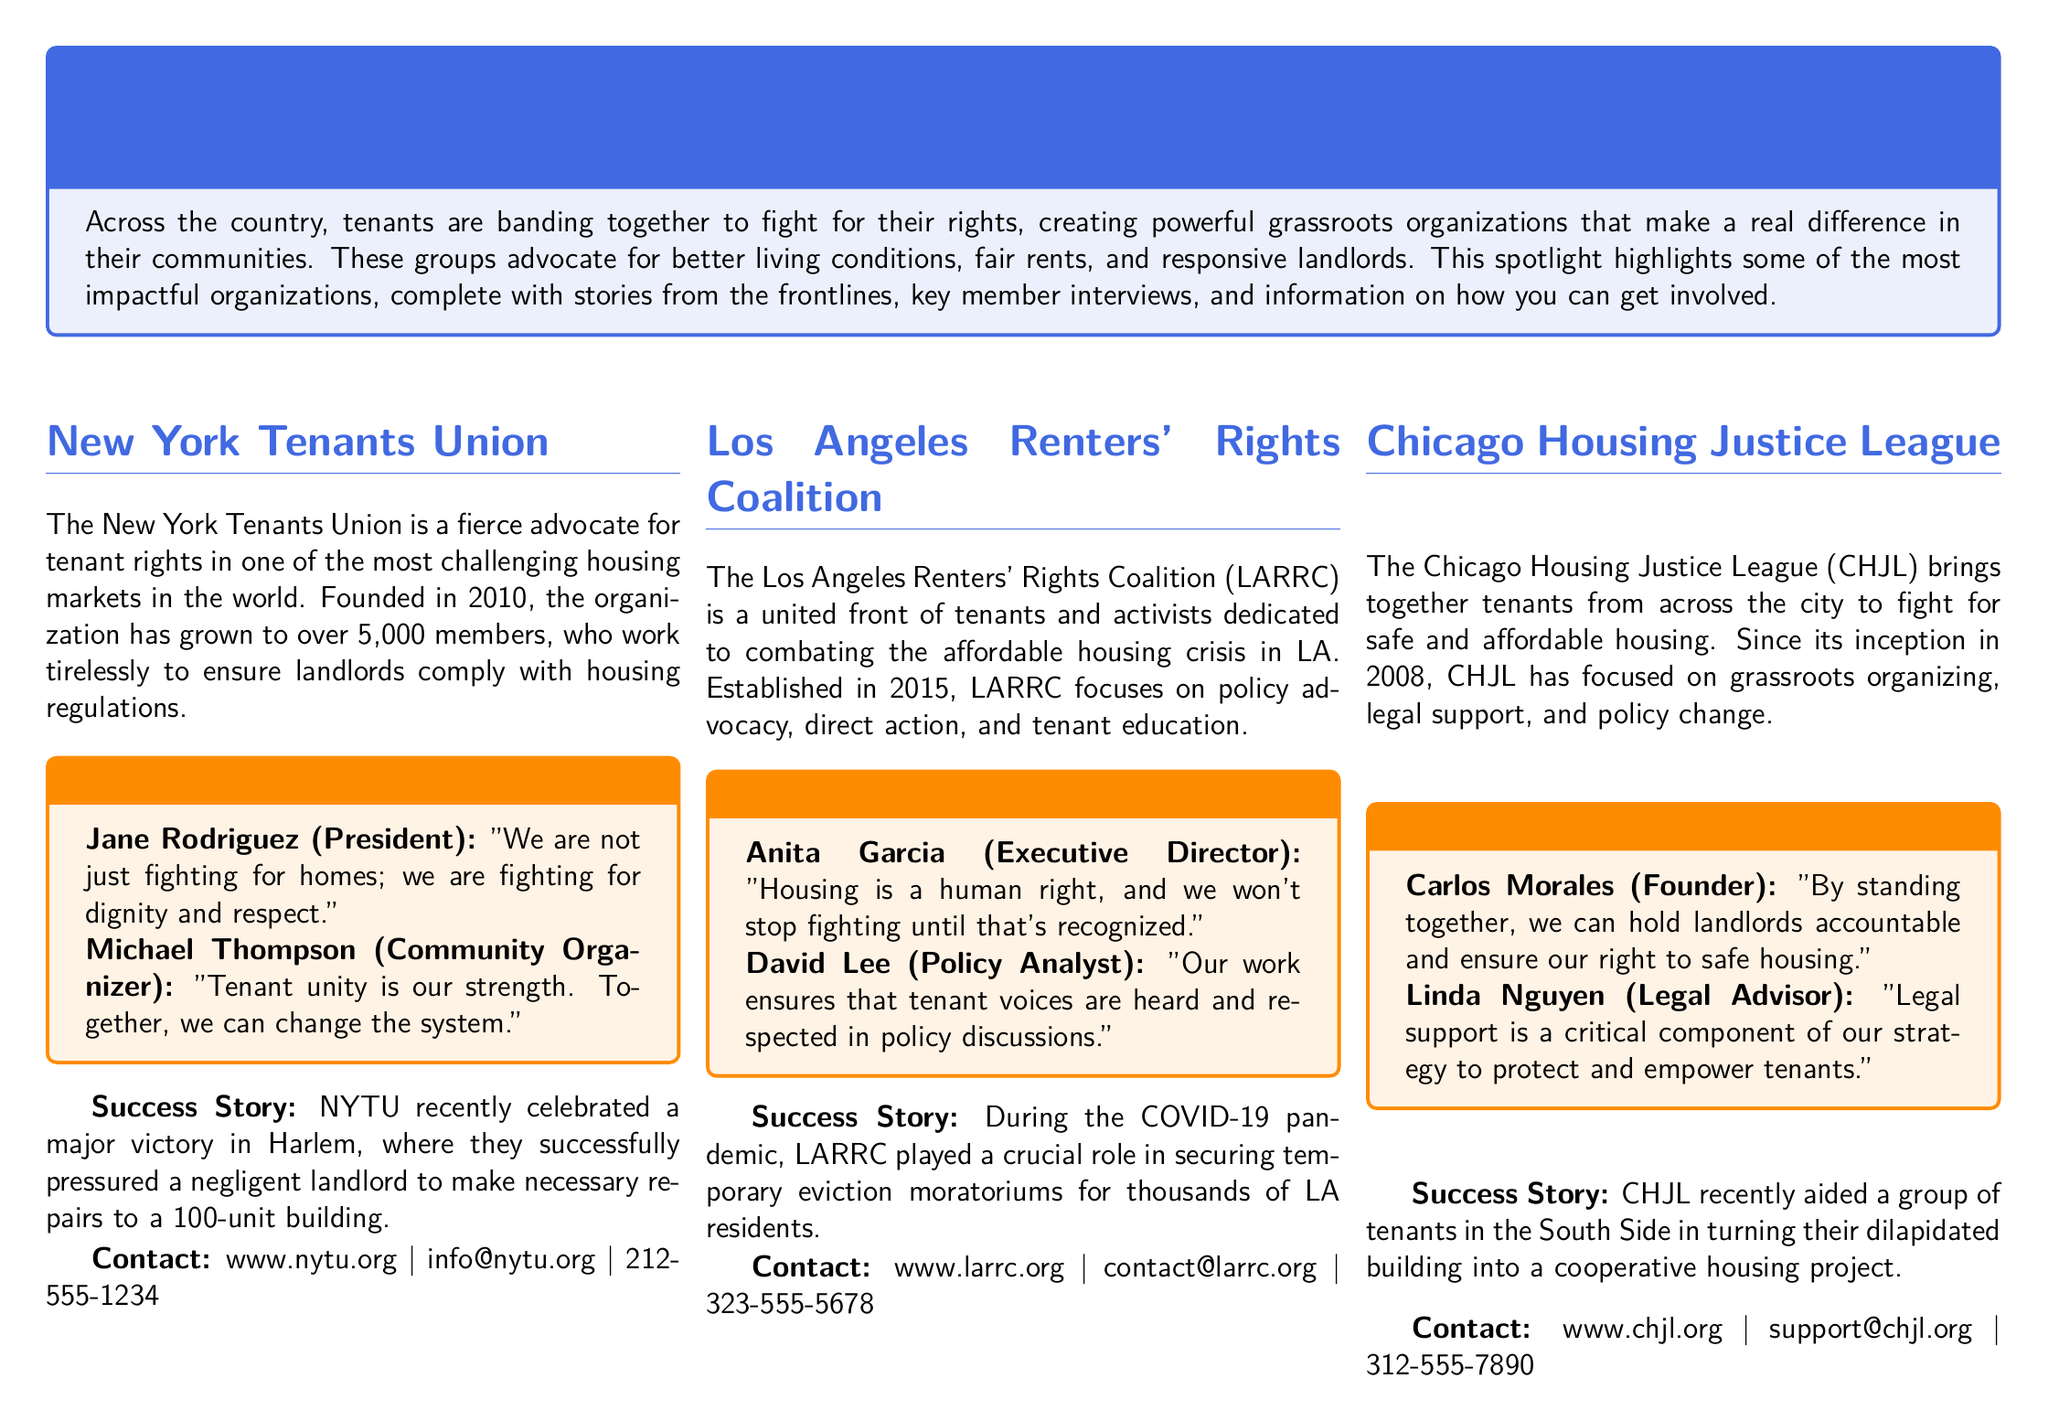What is the name of the organization based in New York? The section specifically highlights the New York Tenants Union, an organization for tenant rights in New York.
Answer: New York Tenants Union What year was the Los Angeles Renters' Rights Coalition established? The document states that LARRC was established in 2015.
Answer: 2015 Who is the Executive Director of the Los Angeles Renters' Rights Coalition? The document mentions Anita Garcia as the Executive Director of LARRC.
Answer: Anita Garcia What significant achievement did the Chicago Housing Justice League help tenants accomplish? The text indicates that CHJL assisted tenants in creating a cooperative housing project from a dilapidated building.
Answer: Cooperative housing project Which major victory occurred in Harlem related to tenant rights? The document describes a successful effort to pressure a negligent landlord for repairs in a 100-unit building.
Answer: Necessary repairs to a 100-unit building What is the website for the Chicago Housing Justice League? The document provides the contact details for CHJL, including their website.
Answer: www.chjl.org What common theme is present among all the grassroots organizations mentioned? A notable theme across these organizations is their collective action for tenant rights and housing justice.
Answer: Collective action How many members does the New York Tenants Union have? According to the document, the New York Tenants Union has grown to over 5,000 members.
Answer: Over 5,000 members 